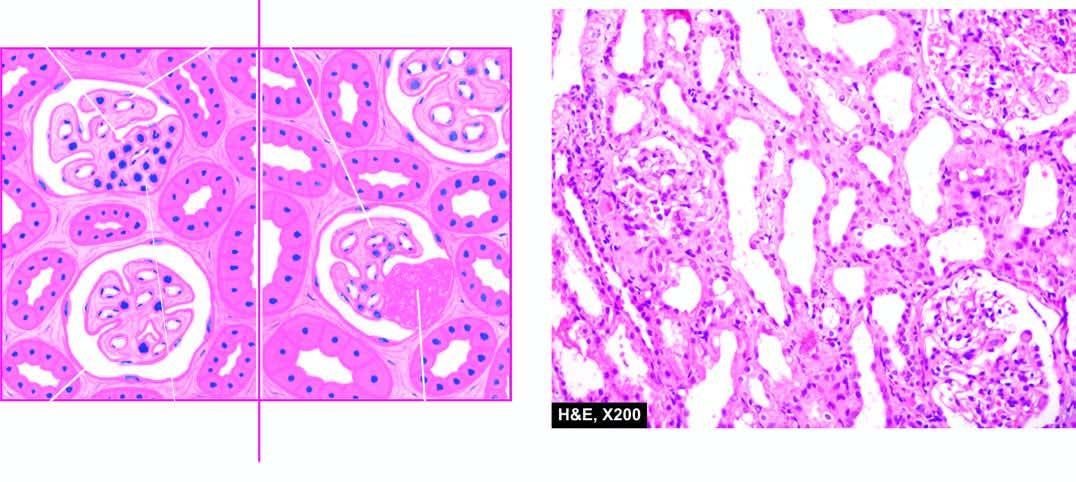how are the features?
Answer the question using a single word or phrase. Focal and segmental involvement of the glomeruli by sclerosis and hyalinosis and mesangial hypercellularity 